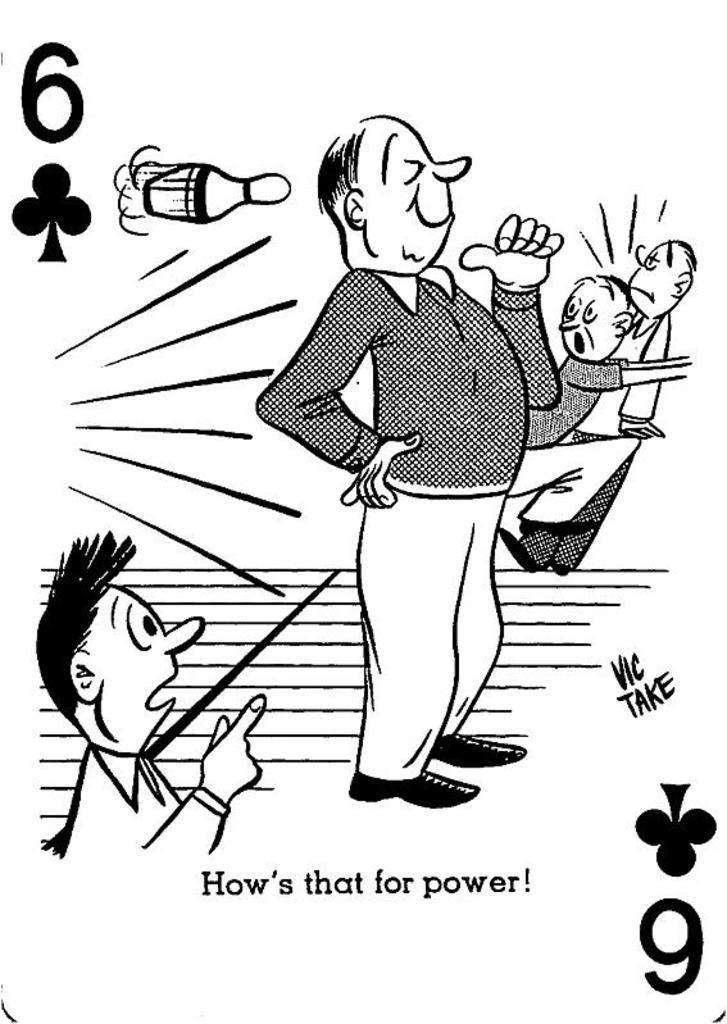How would you summarize this image in a sentence or two? In the picture I can see cartoon image of people and something written on the image. This picture is black and white in color. 